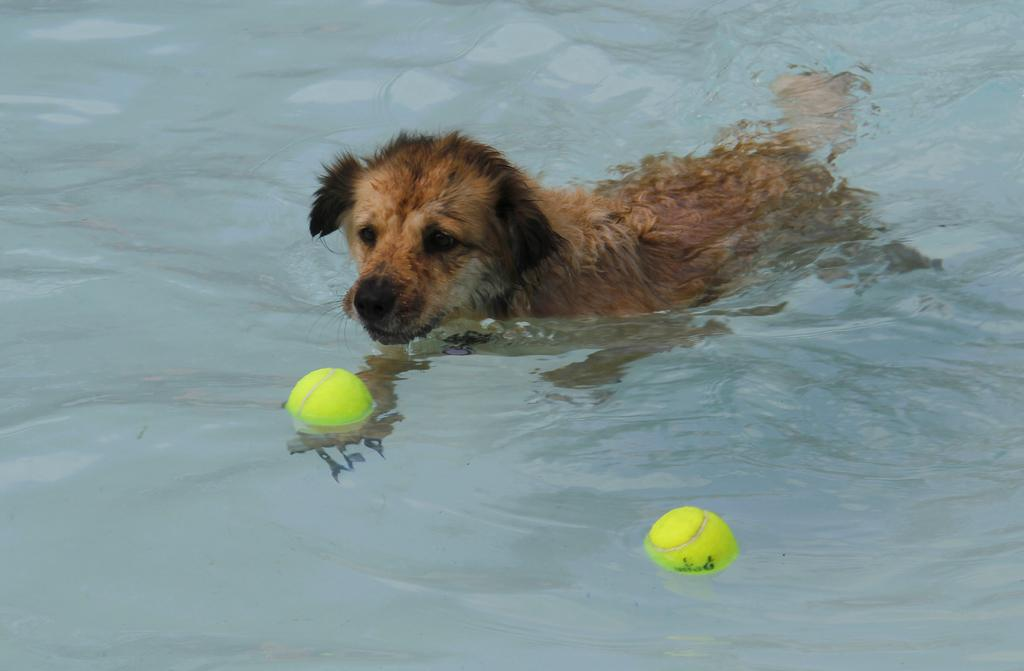What animal can be seen in the image? There is a dog in the image. What is the dog doing in the image? The dog is swimming in the water. What is the color of the dog? The dog is brown in color. What other objects are present in the water? There are two green color balls in the water. How does the dog maintain its balance while swimming with a quilt on its wrist? There is no quilt or any mention of a wrist in the image; the dog is simply swimming in the water. 